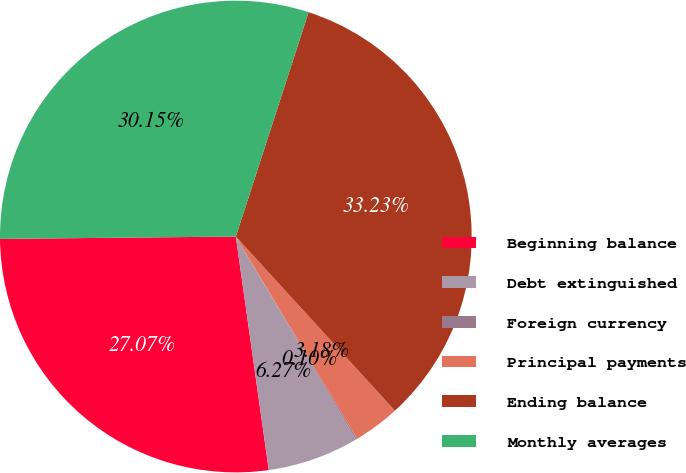Convert chart. <chart><loc_0><loc_0><loc_500><loc_500><pie_chart><fcel>Beginning balance<fcel>Debt extinguished<fcel>Foreign currency<fcel>Principal payments<fcel>Ending balance<fcel>Monthly averages<nl><fcel>27.07%<fcel>6.27%<fcel>0.1%<fcel>3.18%<fcel>33.23%<fcel>30.15%<nl></chart> 